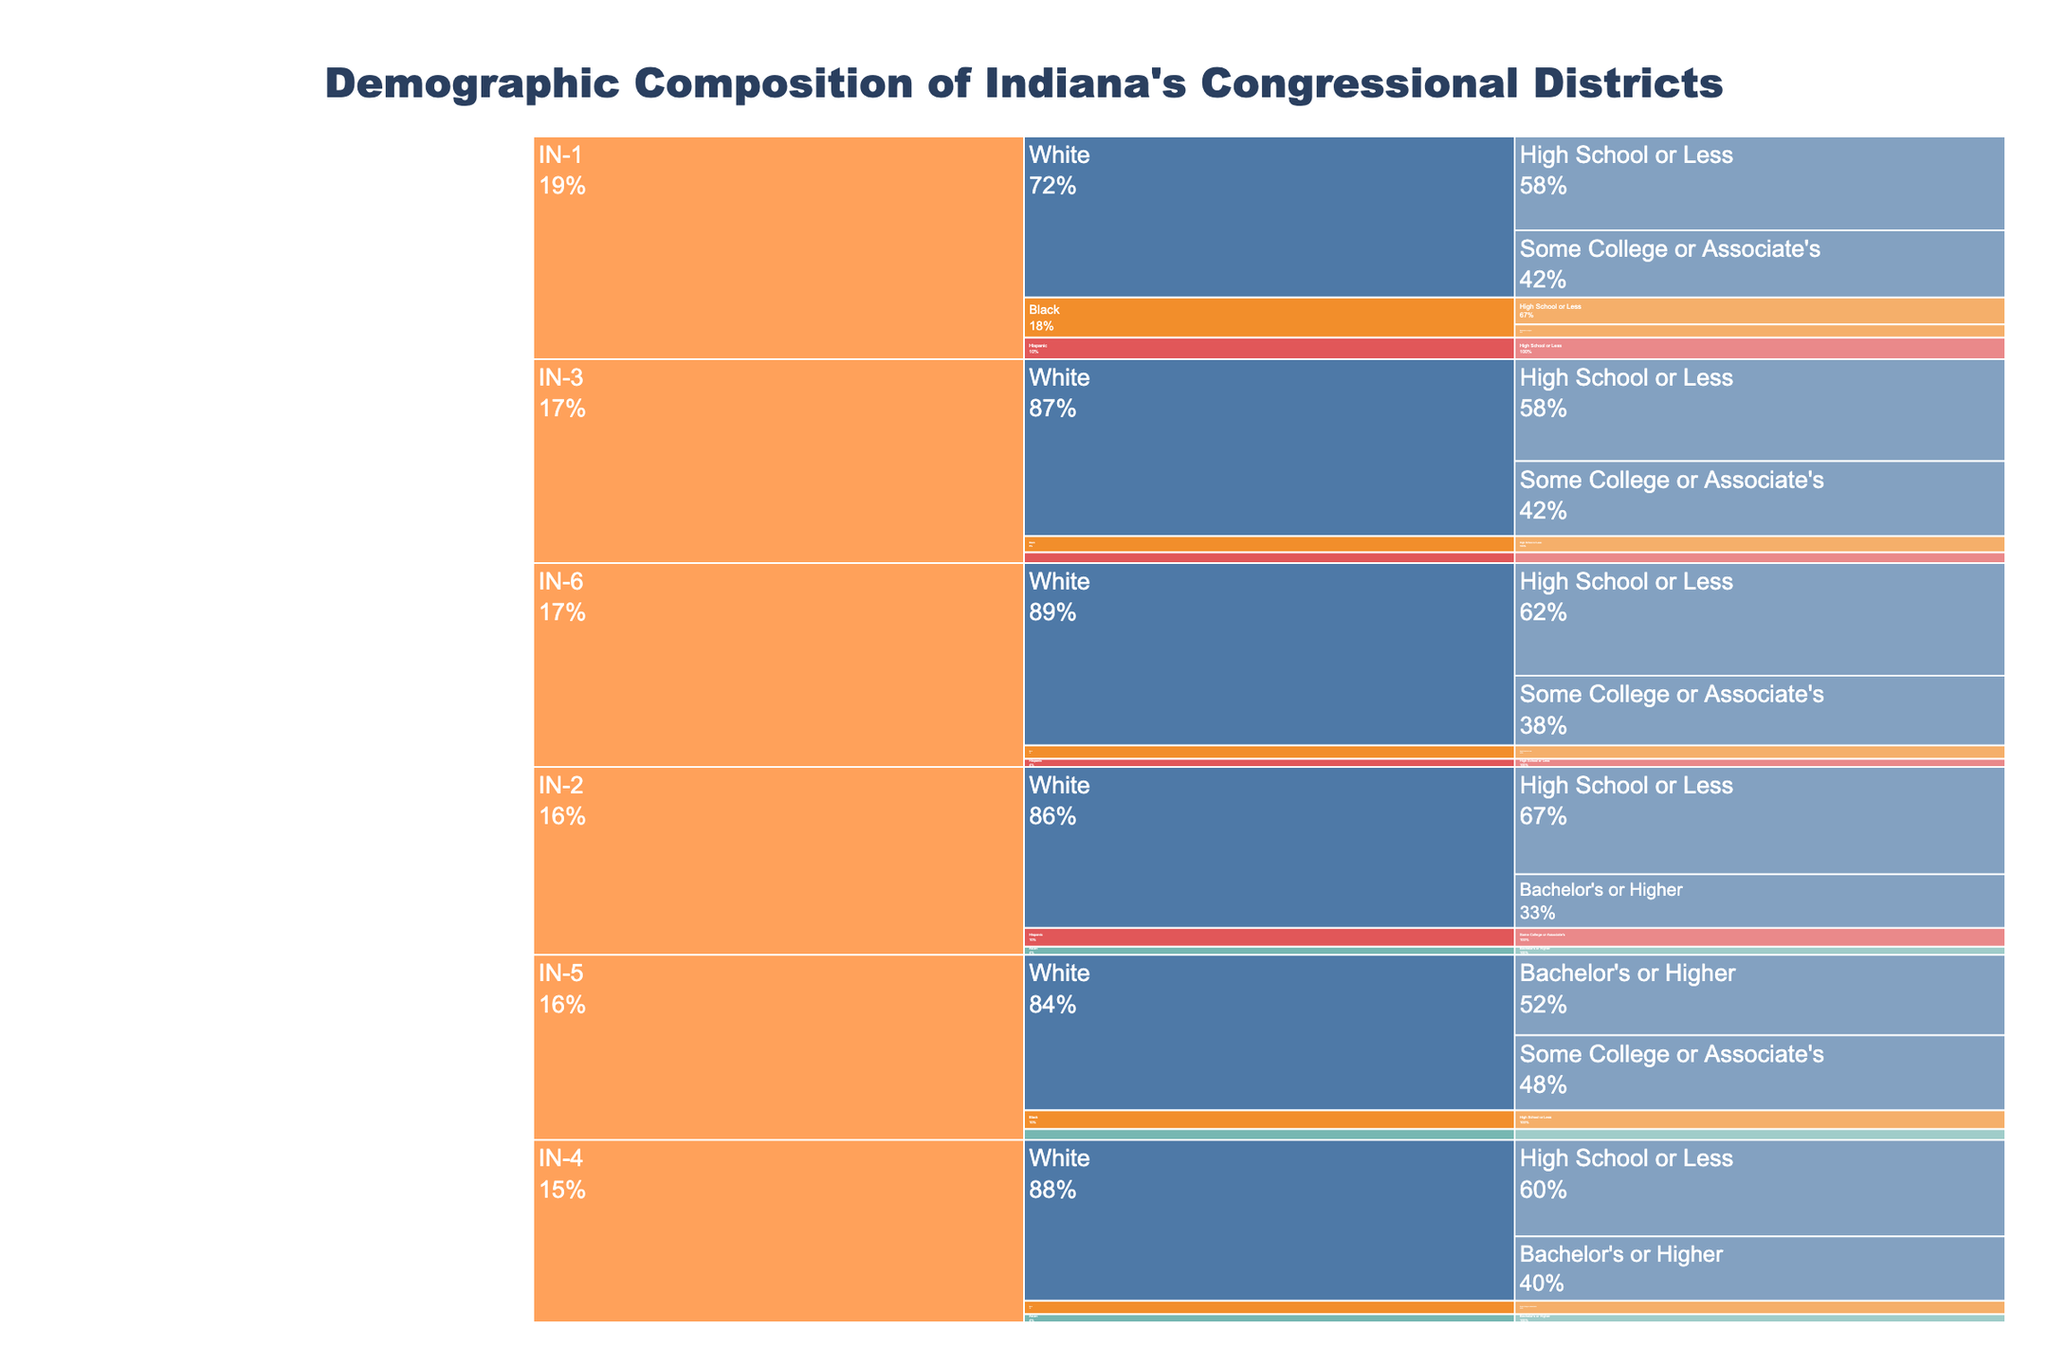What is the overall title of the chart? The title is prominently displayed at the top of the chart.
Answer: Demographic Composition of Indiana's Congressional Districts Which race has the most educational levels displayed in the figure? The races are White, Black, Hispanic, and Asian. By looking at the branches corresponding to each race, White has the most educational subcategories (High School or Less, Some College or Associate's, Bachelor's or Higher).
Answer: White In IN-1, which racial group has the highest percentage for the category "High School or Less"? In IN-1, look for the "High School or Less" category under each racial group. The branches for White, Black, and Hispanic show different values for this category.
Answer: White Compare the percentage of Whites with "Some College or Associate's" in IN-3 to IN-5. Which district has a higher percentage? Look under each district for Whites and then find the subcategory "Some College or Associate's." IN-3 has 28%, and IN-5 has 28%.
Answer: They are equal What is the total percentage of Black individuals in IN-1? Sum the percentages of Black individuals in IN-1 for all educational levels displayed (10% High School or Less + 5% Bachelor's or Higher).
Answer: 15% Which district shows the highest percentage of individuals, regardless of race, with a "Bachelor's or Higher" education? Look at the educational subcategory "Bachelor's or Higher" across all districts, then find the highest value within each racial group's percentage.
Answer: IN-5 In IN-4, which racial group has the lowest represented percentage across all educational categories? Check each racial group's total contribution within IN-4. Compare the percentages across the subcategories for White, Black, and Asian, summing them if necessary.
Answer: Asian What percentage of Hispanics in IN-2 have "Some College or Associate's" education? Look under the IN-2 district for the Hispanic group and find the subcategory "Some College or Associate's."
Answer: 7% Which district has the highest percentage of Whites with "High School or Less" education? Compare the percentages of Whites with "High School or Less" across all the given districts (IN-1, IN-2, IN-3, IN-4, IN-6).
Answer: IN-6 Is there any district where Asians appear in more than one educational category? If yes, which one? Scan the districts for the Asian racial group and verify the count of subcategories they appear in. Asians only appear under "Bachelor's or Higher" in IN-2 and IN-4, and IN-5.
Answer: No 